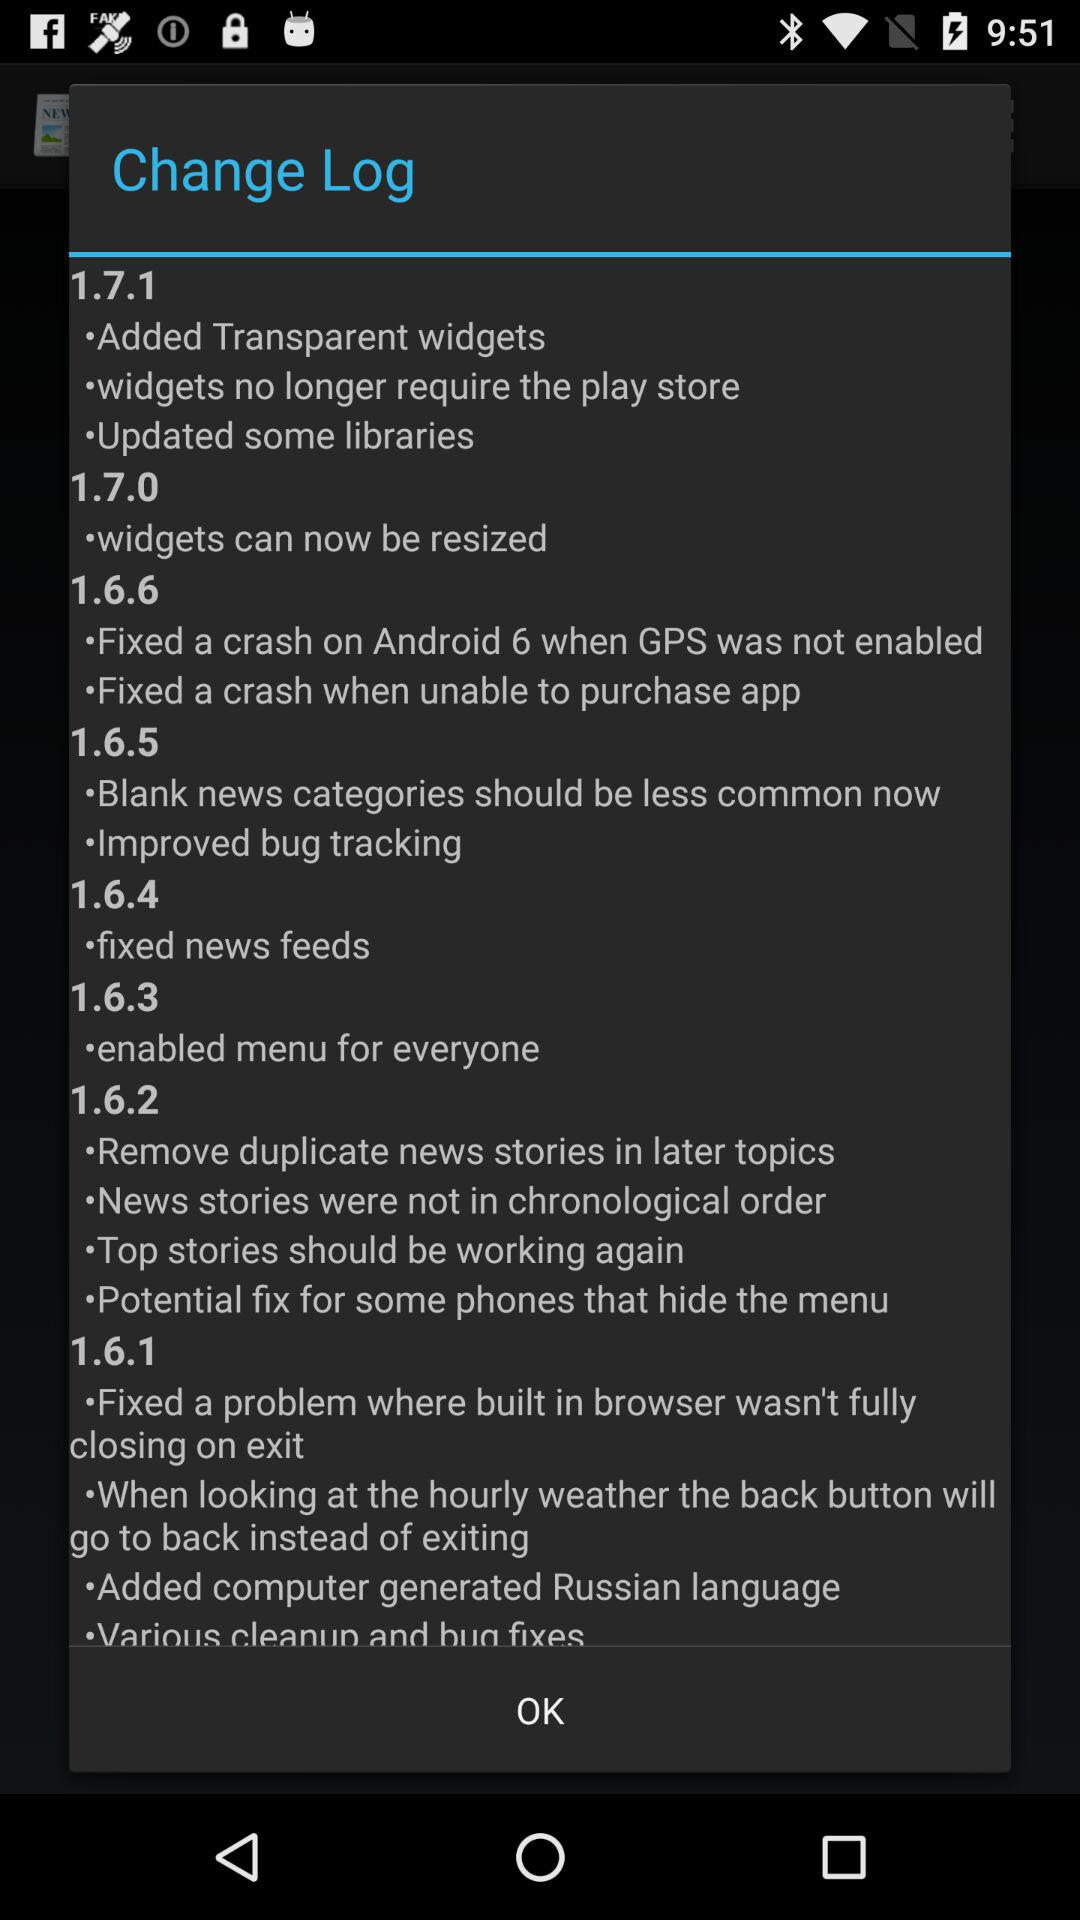What is the change log in version 1.7.1? The change log is "Added Transparent widgets", "widgets no longer require the play store" and "Updated some libraries". 